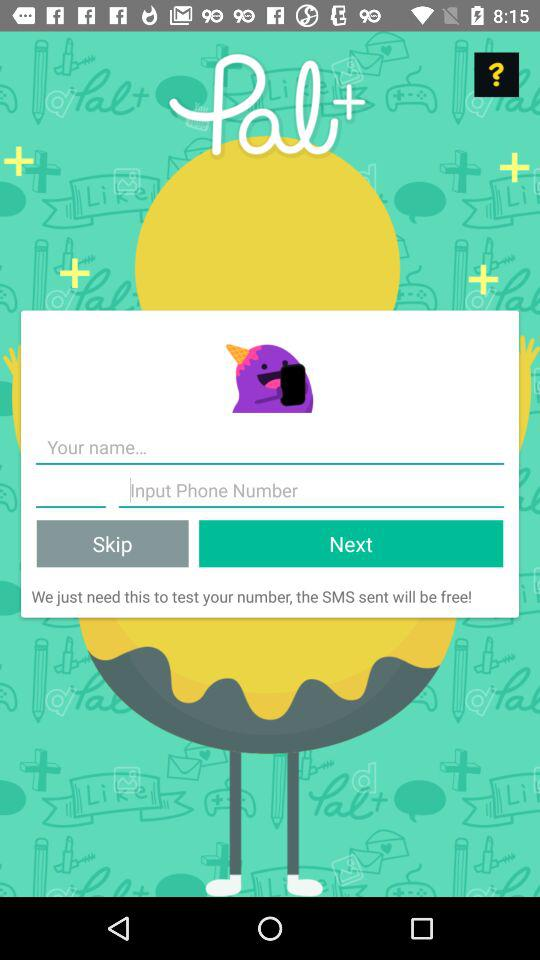What is the application name? The application name is "Pal+". 